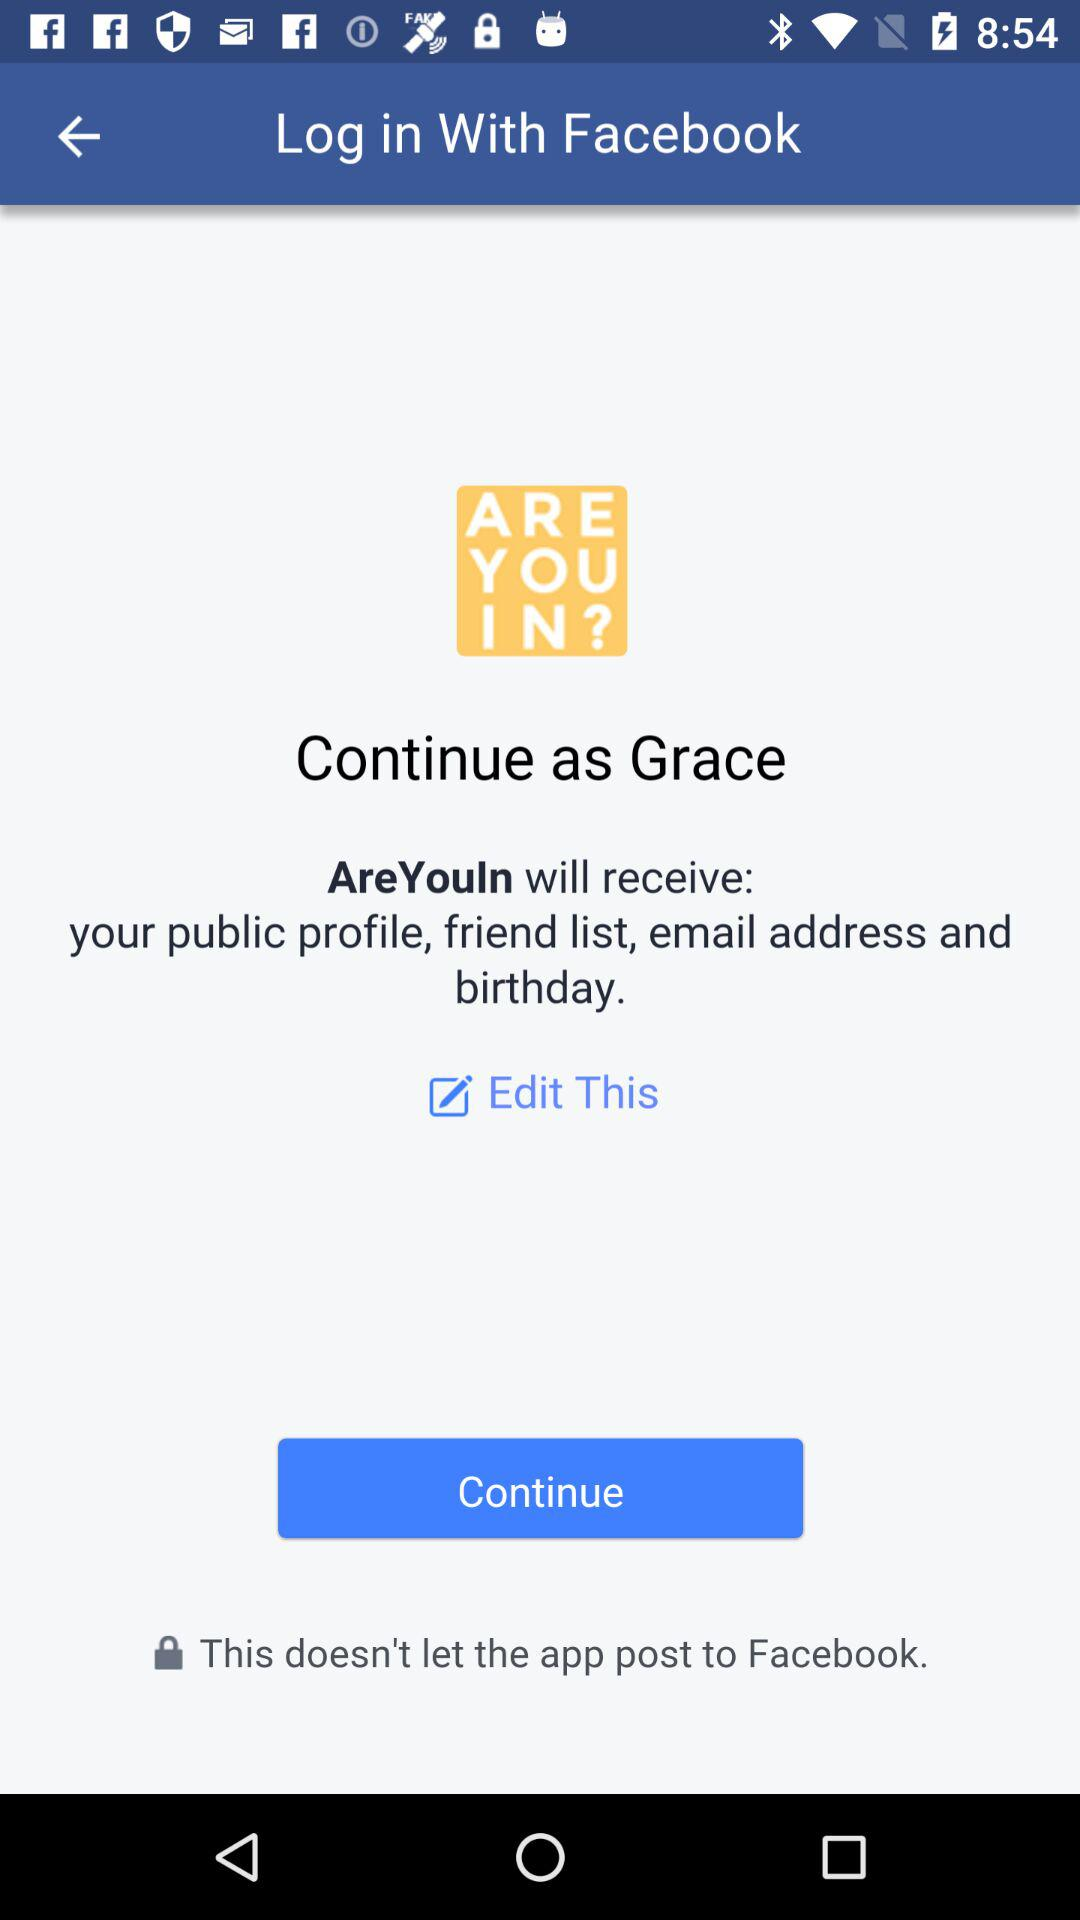Who developed the "AreYouIn" app?
When the provided information is insufficient, respond with <no answer>. <no answer> 